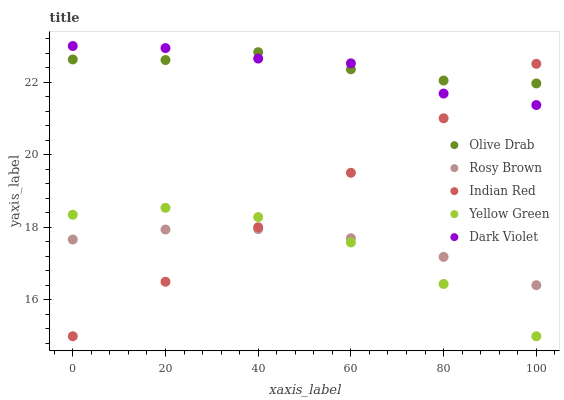Does Yellow Green have the minimum area under the curve?
Answer yes or no. Yes. Does Olive Drab have the maximum area under the curve?
Answer yes or no. Yes. Does Rosy Brown have the minimum area under the curve?
Answer yes or no. No. Does Rosy Brown have the maximum area under the curve?
Answer yes or no. No. Is Indian Red the smoothest?
Answer yes or no. Yes. Is Yellow Green the roughest?
Answer yes or no. Yes. Is Rosy Brown the smoothest?
Answer yes or no. No. Is Rosy Brown the roughest?
Answer yes or no. No. Does Indian Red have the lowest value?
Answer yes or no. Yes. Does Rosy Brown have the lowest value?
Answer yes or no. No. Does Dark Violet have the highest value?
Answer yes or no. Yes. Does Indian Red have the highest value?
Answer yes or no. No. Is Rosy Brown less than Olive Drab?
Answer yes or no. Yes. Is Olive Drab greater than Yellow Green?
Answer yes or no. Yes. Does Dark Violet intersect Indian Red?
Answer yes or no. Yes. Is Dark Violet less than Indian Red?
Answer yes or no. No. Is Dark Violet greater than Indian Red?
Answer yes or no. No. Does Rosy Brown intersect Olive Drab?
Answer yes or no. No. 